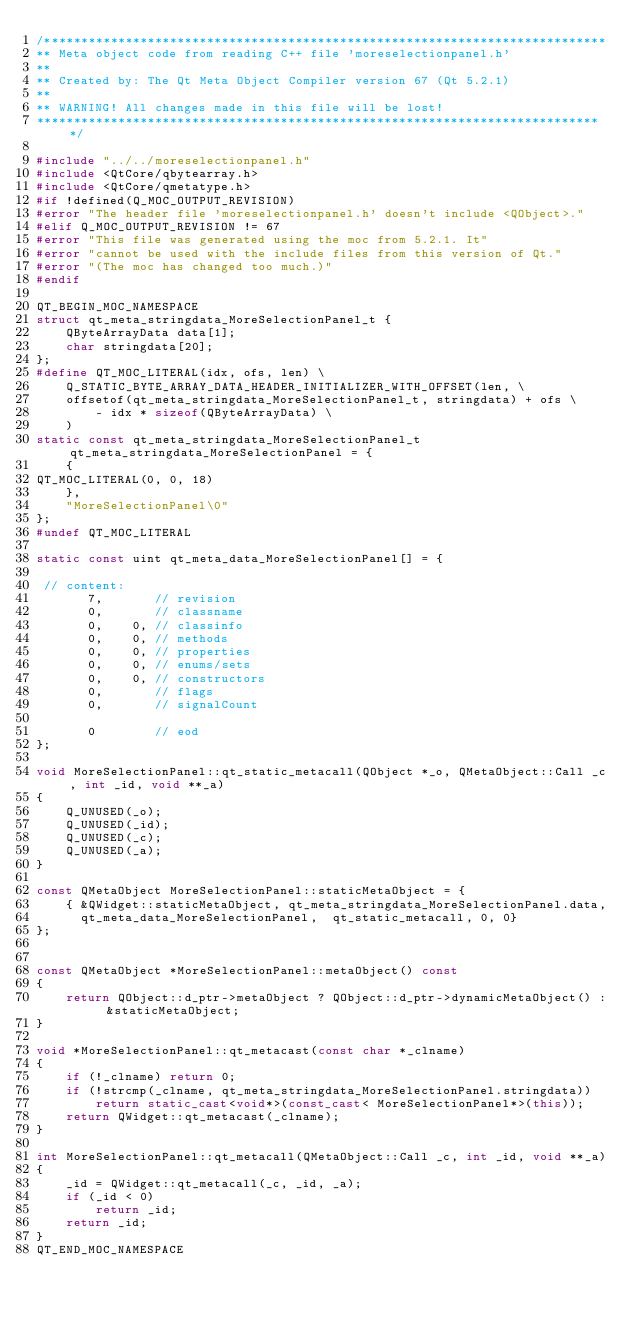Convert code to text. <code><loc_0><loc_0><loc_500><loc_500><_C++_>/****************************************************************************
** Meta object code from reading C++ file 'moreselectionpanel.h'
**
** Created by: The Qt Meta Object Compiler version 67 (Qt 5.2.1)
**
** WARNING! All changes made in this file will be lost!
*****************************************************************************/

#include "../../moreselectionpanel.h"
#include <QtCore/qbytearray.h>
#include <QtCore/qmetatype.h>
#if !defined(Q_MOC_OUTPUT_REVISION)
#error "The header file 'moreselectionpanel.h' doesn't include <QObject>."
#elif Q_MOC_OUTPUT_REVISION != 67
#error "This file was generated using the moc from 5.2.1. It"
#error "cannot be used with the include files from this version of Qt."
#error "(The moc has changed too much.)"
#endif

QT_BEGIN_MOC_NAMESPACE
struct qt_meta_stringdata_MoreSelectionPanel_t {
    QByteArrayData data[1];
    char stringdata[20];
};
#define QT_MOC_LITERAL(idx, ofs, len) \
    Q_STATIC_BYTE_ARRAY_DATA_HEADER_INITIALIZER_WITH_OFFSET(len, \
    offsetof(qt_meta_stringdata_MoreSelectionPanel_t, stringdata) + ofs \
        - idx * sizeof(QByteArrayData) \
    )
static const qt_meta_stringdata_MoreSelectionPanel_t qt_meta_stringdata_MoreSelectionPanel = {
    {
QT_MOC_LITERAL(0, 0, 18)
    },
    "MoreSelectionPanel\0"
};
#undef QT_MOC_LITERAL

static const uint qt_meta_data_MoreSelectionPanel[] = {

 // content:
       7,       // revision
       0,       // classname
       0,    0, // classinfo
       0,    0, // methods
       0,    0, // properties
       0,    0, // enums/sets
       0,    0, // constructors
       0,       // flags
       0,       // signalCount

       0        // eod
};

void MoreSelectionPanel::qt_static_metacall(QObject *_o, QMetaObject::Call _c, int _id, void **_a)
{
    Q_UNUSED(_o);
    Q_UNUSED(_id);
    Q_UNUSED(_c);
    Q_UNUSED(_a);
}

const QMetaObject MoreSelectionPanel::staticMetaObject = {
    { &QWidget::staticMetaObject, qt_meta_stringdata_MoreSelectionPanel.data,
      qt_meta_data_MoreSelectionPanel,  qt_static_metacall, 0, 0}
};


const QMetaObject *MoreSelectionPanel::metaObject() const
{
    return QObject::d_ptr->metaObject ? QObject::d_ptr->dynamicMetaObject() : &staticMetaObject;
}

void *MoreSelectionPanel::qt_metacast(const char *_clname)
{
    if (!_clname) return 0;
    if (!strcmp(_clname, qt_meta_stringdata_MoreSelectionPanel.stringdata))
        return static_cast<void*>(const_cast< MoreSelectionPanel*>(this));
    return QWidget::qt_metacast(_clname);
}

int MoreSelectionPanel::qt_metacall(QMetaObject::Call _c, int _id, void **_a)
{
    _id = QWidget::qt_metacall(_c, _id, _a);
    if (_id < 0)
        return _id;
    return _id;
}
QT_END_MOC_NAMESPACE
</code> 